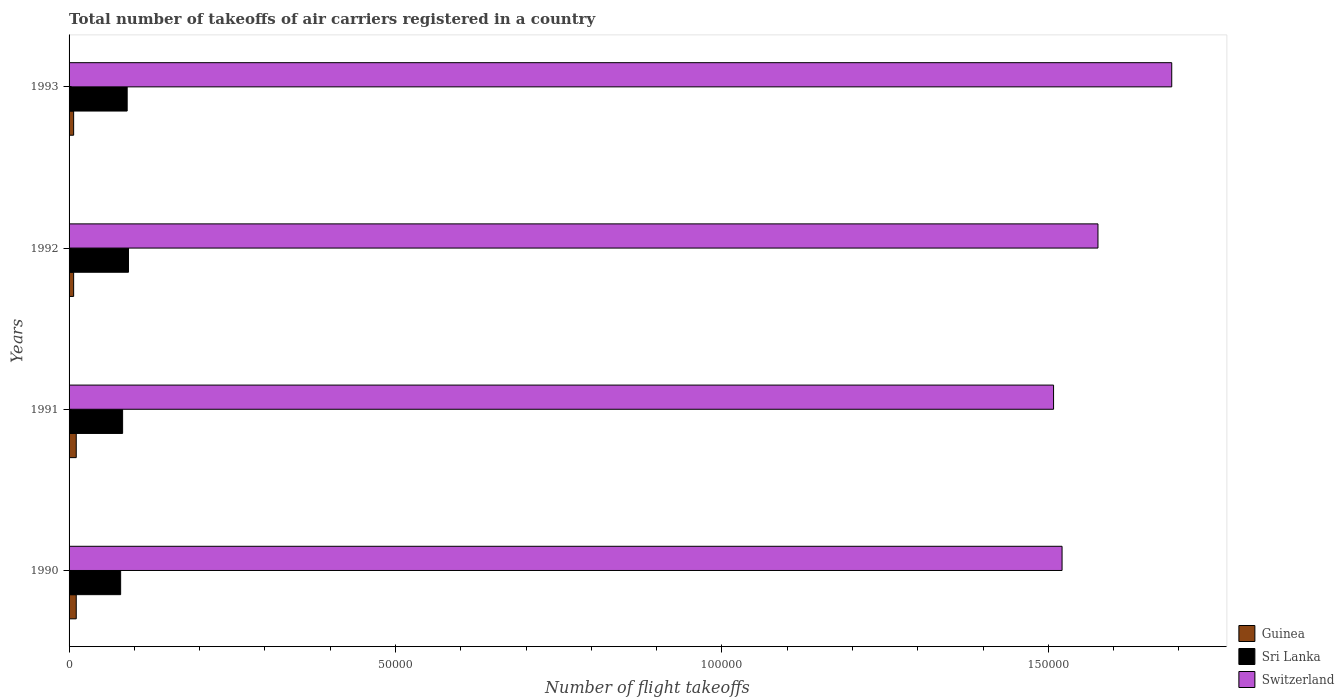How many groups of bars are there?
Provide a short and direct response. 4. Are the number of bars per tick equal to the number of legend labels?
Offer a terse response. Yes. Are the number of bars on each tick of the Y-axis equal?
Your answer should be compact. Yes. How many bars are there on the 4th tick from the bottom?
Your answer should be very brief. 3. What is the label of the 4th group of bars from the top?
Ensure brevity in your answer.  1990. What is the total number of flight takeoffs in Sri Lanka in 1990?
Your response must be concise. 7900. Across all years, what is the maximum total number of flight takeoffs in Switzerland?
Give a very brief answer. 1.69e+05. Across all years, what is the minimum total number of flight takeoffs in Switzerland?
Ensure brevity in your answer.  1.51e+05. In which year was the total number of flight takeoffs in Switzerland maximum?
Give a very brief answer. 1993. In which year was the total number of flight takeoffs in Sri Lanka minimum?
Your response must be concise. 1990. What is the total total number of flight takeoffs in Guinea in the graph?
Offer a terse response. 3600. What is the difference between the total number of flight takeoffs in Switzerland in 1990 and that in 1992?
Offer a terse response. -5500. What is the difference between the total number of flight takeoffs in Sri Lanka in 1993 and the total number of flight takeoffs in Switzerland in 1991?
Ensure brevity in your answer.  -1.42e+05. What is the average total number of flight takeoffs in Guinea per year?
Offer a very short reply. 900. In the year 1992, what is the difference between the total number of flight takeoffs in Switzerland and total number of flight takeoffs in Sri Lanka?
Give a very brief answer. 1.48e+05. In how many years, is the total number of flight takeoffs in Switzerland greater than 90000 ?
Offer a very short reply. 4. What is the ratio of the total number of flight takeoffs in Switzerland in 1992 to that in 1993?
Provide a succinct answer. 0.93. Is the difference between the total number of flight takeoffs in Switzerland in 1990 and 1992 greater than the difference between the total number of flight takeoffs in Sri Lanka in 1990 and 1992?
Keep it short and to the point. No. What does the 2nd bar from the top in 1993 represents?
Your answer should be very brief. Sri Lanka. What does the 3rd bar from the bottom in 1990 represents?
Offer a very short reply. Switzerland. How many bars are there?
Ensure brevity in your answer.  12. Are all the bars in the graph horizontal?
Make the answer very short. Yes. Are the values on the major ticks of X-axis written in scientific E-notation?
Make the answer very short. No. Does the graph contain any zero values?
Make the answer very short. No. Where does the legend appear in the graph?
Keep it short and to the point. Bottom right. What is the title of the graph?
Provide a succinct answer. Total number of takeoffs of air carriers registered in a country. Does "High income: nonOECD" appear as one of the legend labels in the graph?
Make the answer very short. No. What is the label or title of the X-axis?
Your answer should be very brief. Number of flight takeoffs. What is the label or title of the Y-axis?
Your answer should be very brief. Years. What is the Number of flight takeoffs in Guinea in 1990?
Offer a terse response. 1100. What is the Number of flight takeoffs in Sri Lanka in 1990?
Provide a short and direct response. 7900. What is the Number of flight takeoffs in Switzerland in 1990?
Your response must be concise. 1.52e+05. What is the Number of flight takeoffs in Guinea in 1991?
Your response must be concise. 1100. What is the Number of flight takeoffs in Sri Lanka in 1991?
Provide a short and direct response. 8200. What is the Number of flight takeoffs in Switzerland in 1991?
Provide a succinct answer. 1.51e+05. What is the Number of flight takeoffs in Guinea in 1992?
Your answer should be very brief. 700. What is the Number of flight takeoffs of Sri Lanka in 1992?
Provide a short and direct response. 9100. What is the Number of flight takeoffs of Switzerland in 1992?
Your answer should be very brief. 1.58e+05. What is the Number of flight takeoffs in Guinea in 1993?
Your answer should be very brief. 700. What is the Number of flight takeoffs of Sri Lanka in 1993?
Your response must be concise. 8900. What is the Number of flight takeoffs in Switzerland in 1993?
Provide a succinct answer. 1.69e+05. Across all years, what is the maximum Number of flight takeoffs of Guinea?
Your answer should be compact. 1100. Across all years, what is the maximum Number of flight takeoffs in Sri Lanka?
Your answer should be compact. 9100. Across all years, what is the maximum Number of flight takeoffs of Switzerland?
Your response must be concise. 1.69e+05. Across all years, what is the minimum Number of flight takeoffs of Guinea?
Provide a succinct answer. 700. Across all years, what is the minimum Number of flight takeoffs in Sri Lanka?
Provide a succinct answer. 7900. Across all years, what is the minimum Number of flight takeoffs in Switzerland?
Keep it short and to the point. 1.51e+05. What is the total Number of flight takeoffs of Guinea in the graph?
Offer a terse response. 3600. What is the total Number of flight takeoffs in Sri Lanka in the graph?
Your response must be concise. 3.41e+04. What is the total Number of flight takeoffs in Switzerland in the graph?
Your response must be concise. 6.29e+05. What is the difference between the Number of flight takeoffs in Sri Lanka in 1990 and that in 1991?
Your answer should be very brief. -300. What is the difference between the Number of flight takeoffs of Switzerland in 1990 and that in 1991?
Your answer should be very brief. 1300. What is the difference between the Number of flight takeoffs of Guinea in 1990 and that in 1992?
Your response must be concise. 400. What is the difference between the Number of flight takeoffs in Sri Lanka in 1990 and that in 1992?
Offer a very short reply. -1200. What is the difference between the Number of flight takeoffs in Switzerland in 1990 and that in 1992?
Provide a short and direct response. -5500. What is the difference between the Number of flight takeoffs in Sri Lanka in 1990 and that in 1993?
Give a very brief answer. -1000. What is the difference between the Number of flight takeoffs of Switzerland in 1990 and that in 1993?
Your response must be concise. -1.68e+04. What is the difference between the Number of flight takeoffs of Sri Lanka in 1991 and that in 1992?
Provide a succinct answer. -900. What is the difference between the Number of flight takeoffs in Switzerland in 1991 and that in 1992?
Keep it short and to the point. -6800. What is the difference between the Number of flight takeoffs in Sri Lanka in 1991 and that in 1993?
Keep it short and to the point. -700. What is the difference between the Number of flight takeoffs of Switzerland in 1991 and that in 1993?
Give a very brief answer. -1.81e+04. What is the difference between the Number of flight takeoffs in Guinea in 1992 and that in 1993?
Keep it short and to the point. 0. What is the difference between the Number of flight takeoffs of Sri Lanka in 1992 and that in 1993?
Ensure brevity in your answer.  200. What is the difference between the Number of flight takeoffs of Switzerland in 1992 and that in 1993?
Offer a terse response. -1.13e+04. What is the difference between the Number of flight takeoffs in Guinea in 1990 and the Number of flight takeoffs in Sri Lanka in 1991?
Your answer should be very brief. -7100. What is the difference between the Number of flight takeoffs in Guinea in 1990 and the Number of flight takeoffs in Switzerland in 1991?
Keep it short and to the point. -1.50e+05. What is the difference between the Number of flight takeoffs in Sri Lanka in 1990 and the Number of flight takeoffs in Switzerland in 1991?
Ensure brevity in your answer.  -1.43e+05. What is the difference between the Number of flight takeoffs of Guinea in 1990 and the Number of flight takeoffs of Sri Lanka in 1992?
Your response must be concise. -8000. What is the difference between the Number of flight takeoffs of Guinea in 1990 and the Number of flight takeoffs of Switzerland in 1992?
Provide a succinct answer. -1.56e+05. What is the difference between the Number of flight takeoffs in Sri Lanka in 1990 and the Number of flight takeoffs in Switzerland in 1992?
Provide a succinct answer. -1.50e+05. What is the difference between the Number of flight takeoffs in Guinea in 1990 and the Number of flight takeoffs in Sri Lanka in 1993?
Make the answer very short. -7800. What is the difference between the Number of flight takeoffs of Guinea in 1990 and the Number of flight takeoffs of Switzerland in 1993?
Your answer should be compact. -1.68e+05. What is the difference between the Number of flight takeoffs in Sri Lanka in 1990 and the Number of flight takeoffs in Switzerland in 1993?
Make the answer very short. -1.61e+05. What is the difference between the Number of flight takeoffs in Guinea in 1991 and the Number of flight takeoffs in Sri Lanka in 1992?
Offer a very short reply. -8000. What is the difference between the Number of flight takeoffs of Guinea in 1991 and the Number of flight takeoffs of Switzerland in 1992?
Make the answer very short. -1.56e+05. What is the difference between the Number of flight takeoffs of Sri Lanka in 1991 and the Number of flight takeoffs of Switzerland in 1992?
Your answer should be compact. -1.49e+05. What is the difference between the Number of flight takeoffs of Guinea in 1991 and the Number of flight takeoffs of Sri Lanka in 1993?
Your response must be concise. -7800. What is the difference between the Number of flight takeoffs in Guinea in 1991 and the Number of flight takeoffs in Switzerland in 1993?
Give a very brief answer. -1.68e+05. What is the difference between the Number of flight takeoffs of Sri Lanka in 1991 and the Number of flight takeoffs of Switzerland in 1993?
Give a very brief answer. -1.61e+05. What is the difference between the Number of flight takeoffs of Guinea in 1992 and the Number of flight takeoffs of Sri Lanka in 1993?
Your response must be concise. -8200. What is the difference between the Number of flight takeoffs in Guinea in 1992 and the Number of flight takeoffs in Switzerland in 1993?
Your answer should be compact. -1.68e+05. What is the difference between the Number of flight takeoffs in Sri Lanka in 1992 and the Number of flight takeoffs in Switzerland in 1993?
Your answer should be very brief. -1.60e+05. What is the average Number of flight takeoffs in Guinea per year?
Your answer should be very brief. 900. What is the average Number of flight takeoffs of Sri Lanka per year?
Give a very brief answer. 8525. What is the average Number of flight takeoffs in Switzerland per year?
Your answer should be compact. 1.57e+05. In the year 1990, what is the difference between the Number of flight takeoffs in Guinea and Number of flight takeoffs in Sri Lanka?
Provide a short and direct response. -6800. In the year 1990, what is the difference between the Number of flight takeoffs in Guinea and Number of flight takeoffs in Switzerland?
Ensure brevity in your answer.  -1.51e+05. In the year 1990, what is the difference between the Number of flight takeoffs in Sri Lanka and Number of flight takeoffs in Switzerland?
Ensure brevity in your answer.  -1.44e+05. In the year 1991, what is the difference between the Number of flight takeoffs in Guinea and Number of flight takeoffs in Sri Lanka?
Ensure brevity in your answer.  -7100. In the year 1991, what is the difference between the Number of flight takeoffs in Guinea and Number of flight takeoffs in Switzerland?
Ensure brevity in your answer.  -1.50e+05. In the year 1991, what is the difference between the Number of flight takeoffs of Sri Lanka and Number of flight takeoffs of Switzerland?
Offer a very short reply. -1.43e+05. In the year 1992, what is the difference between the Number of flight takeoffs in Guinea and Number of flight takeoffs in Sri Lanka?
Provide a succinct answer. -8400. In the year 1992, what is the difference between the Number of flight takeoffs of Guinea and Number of flight takeoffs of Switzerland?
Ensure brevity in your answer.  -1.57e+05. In the year 1992, what is the difference between the Number of flight takeoffs in Sri Lanka and Number of flight takeoffs in Switzerland?
Ensure brevity in your answer.  -1.48e+05. In the year 1993, what is the difference between the Number of flight takeoffs of Guinea and Number of flight takeoffs of Sri Lanka?
Give a very brief answer. -8200. In the year 1993, what is the difference between the Number of flight takeoffs in Guinea and Number of flight takeoffs in Switzerland?
Your response must be concise. -1.68e+05. In the year 1993, what is the difference between the Number of flight takeoffs in Sri Lanka and Number of flight takeoffs in Switzerland?
Provide a short and direct response. -1.60e+05. What is the ratio of the Number of flight takeoffs of Sri Lanka in 1990 to that in 1991?
Your answer should be very brief. 0.96. What is the ratio of the Number of flight takeoffs of Switzerland in 1990 to that in 1991?
Your answer should be compact. 1.01. What is the ratio of the Number of flight takeoffs of Guinea in 1990 to that in 1992?
Keep it short and to the point. 1.57. What is the ratio of the Number of flight takeoffs in Sri Lanka in 1990 to that in 1992?
Ensure brevity in your answer.  0.87. What is the ratio of the Number of flight takeoffs of Switzerland in 1990 to that in 1992?
Ensure brevity in your answer.  0.97. What is the ratio of the Number of flight takeoffs in Guinea in 1990 to that in 1993?
Give a very brief answer. 1.57. What is the ratio of the Number of flight takeoffs in Sri Lanka in 1990 to that in 1993?
Give a very brief answer. 0.89. What is the ratio of the Number of flight takeoffs in Switzerland in 1990 to that in 1993?
Keep it short and to the point. 0.9. What is the ratio of the Number of flight takeoffs of Guinea in 1991 to that in 1992?
Ensure brevity in your answer.  1.57. What is the ratio of the Number of flight takeoffs of Sri Lanka in 1991 to that in 1992?
Give a very brief answer. 0.9. What is the ratio of the Number of flight takeoffs in Switzerland in 1991 to that in 1992?
Make the answer very short. 0.96. What is the ratio of the Number of flight takeoffs of Guinea in 1991 to that in 1993?
Make the answer very short. 1.57. What is the ratio of the Number of flight takeoffs in Sri Lanka in 1991 to that in 1993?
Ensure brevity in your answer.  0.92. What is the ratio of the Number of flight takeoffs in Switzerland in 1991 to that in 1993?
Your response must be concise. 0.89. What is the ratio of the Number of flight takeoffs in Sri Lanka in 1992 to that in 1993?
Your answer should be very brief. 1.02. What is the ratio of the Number of flight takeoffs of Switzerland in 1992 to that in 1993?
Your answer should be very brief. 0.93. What is the difference between the highest and the second highest Number of flight takeoffs in Guinea?
Provide a succinct answer. 0. What is the difference between the highest and the second highest Number of flight takeoffs of Sri Lanka?
Provide a short and direct response. 200. What is the difference between the highest and the second highest Number of flight takeoffs of Switzerland?
Ensure brevity in your answer.  1.13e+04. What is the difference between the highest and the lowest Number of flight takeoffs in Guinea?
Your answer should be compact. 400. What is the difference between the highest and the lowest Number of flight takeoffs of Sri Lanka?
Your answer should be compact. 1200. What is the difference between the highest and the lowest Number of flight takeoffs of Switzerland?
Give a very brief answer. 1.81e+04. 